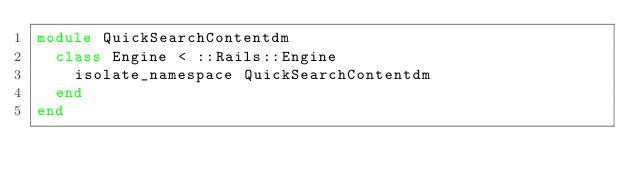<code> <loc_0><loc_0><loc_500><loc_500><_Ruby_>module QuickSearchContentdm
  class Engine < ::Rails::Engine
    isolate_namespace QuickSearchContentdm
  end
end
</code> 